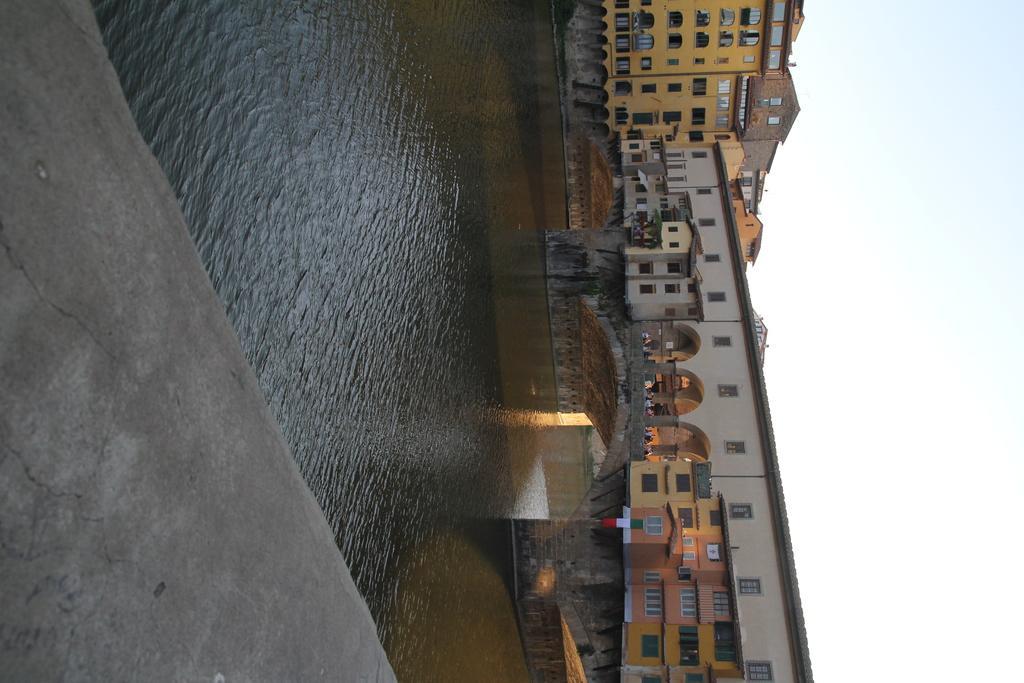Please provide a concise description of this image. In the image there is a pavement, behind that there is a river and across the river there is a bridge and in the background there are buildings. 